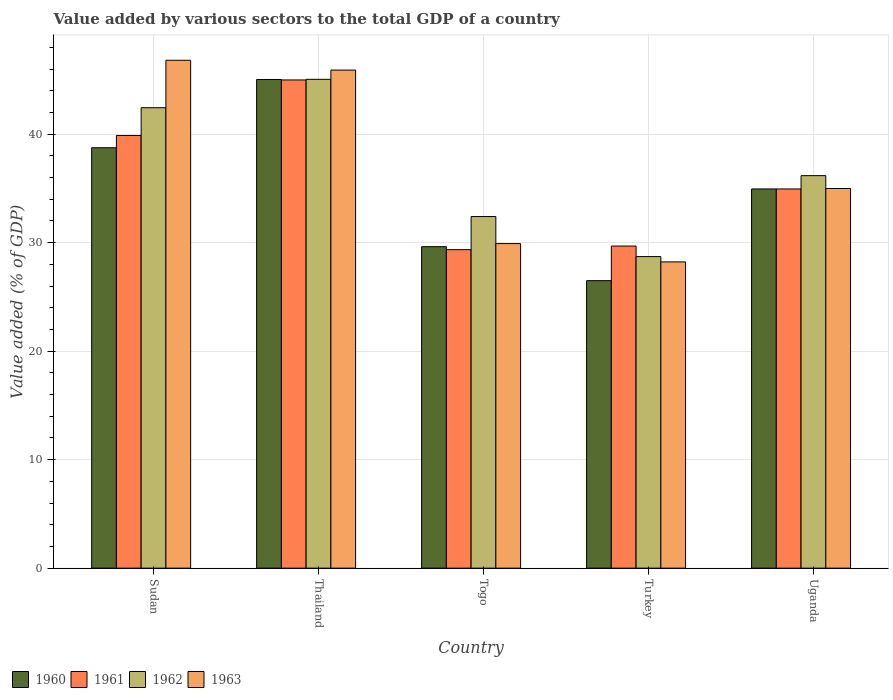Are the number of bars on each tick of the X-axis equal?
Give a very brief answer. Yes. How many bars are there on the 1st tick from the left?
Your answer should be compact. 4. What is the label of the 1st group of bars from the left?
Your answer should be very brief. Sudan. In how many cases, is the number of bars for a given country not equal to the number of legend labels?
Make the answer very short. 0. What is the value added by various sectors to the total GDP in 1962 in Turkey?
Make the answer very short. 28.72. Across all countries, what is the maximum value added by various sectors to the total GDP in 1960?
Ensure brevity in your answer.  45.04. Across all countries, what is the minimum value added by various sectors to the total GDP in 1963?
Offer a very short reply. 28.23. In which country was the value added by various sectors to the total GDP in 1963 maximum?
Offer a very short reply. Sudan. In which country was the value added by various sectors to the total GDP in 1961 minimum?
Your answer should be very brief. Togo. What is the total value added by various sectors to the total GDP in 1962 in the graph?
Offer a very short reply. 184.79. What is the difference between the value added by various sectors to the total GDP in 1960 in Sudan and that in Togo?
Ensure brevity in your answer.  9.12. What is the difference between the value added by various sectors to the total GDP in 1960 in Togo and the value added by various sectors to the total GDP in 1963 in Thailand?
Your response must be concise. -16.28. What is the average value added by various sectors to the total GDP in 1963 per country?
Your answer should be very brief. 37.17. What is the difference between the value added by various sectors to the total GDP of/in 1962 and value added by various sectors to the total GDP of/in 1960 in Turkey?
Your answer should be very brief. 2.22. What is the ratio of the value added by various sectors to the total GDP in 1963 in Thailand to that in Uganda?
Provide a succinct answer. 1.31. Is the difference between the value added by various sectors to the total GDP in 1962 in Thailand and Togo greater than the difference between the value added by various sectors to the total GDP in 1960 in Thailand and Togo?
Provide a succinct answer. No. What is the difference between the highest and the second highest value added by various sectors to the total GDP in 1961?
Offer a very short reply. -10.05. What is the difference between the highest and the lowest value added by various sectors to the total GDP in 1962?
Provide a short and direct response. 16.34. In how many countries, is the value added by various sectors to the total GDP in 1962 greater than the average value added by various sectors to the total GDP in 1962 taken over all countries?
Keep it short and to the point. 2. Is it the case that in every country, the sum of the value added by various sectors to the total GDP in 1962 and value added by various sectors to the total GDP in 1961 is greater than the sum of value added by various sectors to the total GDP in 1960 and value added by various sectors to the total GDP in 1963?
Ensure brevity in your answer.  No. What does the 3rd bar from the left in Turkey represents?
Your answer should be compact. 1962. What does the 2nd bar from the right in Thailand represents?
Your answer should be compact. 1962. Is it the case that in every country, the sum of the value added by various sectors to the total GDP in 1960 and value added by various sectors to the total GDP in 1962 is greater than the value added by various sectors to the total GDP in 1963?
Offer a very short reply. Yes. How many bars are there?
Ensure brevity in your answer.  20. Are all the bars in the graph horizontal?
Your answer should be compact. No. How many countries are there in the graph?
Keep it short and to the point. 5. What is the difference between two consecutive major ticks on the Y-axis?
Provide a short and direct response. 10. Does the graph contain grids?
Your response must be concise. Yes. Where does the legend appear in the graph?
Ensure brevity in your answer.  Bottom left. How are the legend labels stacked?
Your response must be concise. Horizontal. What is the title of the graph?
Offer a very short reply. Value added by various sectors to the total GDP of a country. What is the label or title of the X-axis?
Your answer should be compact. Country. What is the label or title of the Y-axis?
Make the answer very short. Value added (% of GDP). What is the Value added (% of GDP) in 1960 in Sudan?
Provide a short and direct response. 38.75. What is the Value added (% of GDP) in 1961 in Sudan?
Offer a terse response. 39.88. What is the Value added (% of GDP) of 1962 in Sudan?
Provide a short and direct response. 42.44. What is the Value added (% of GDP) in 1963 in Sudan?
Offer a terse response. 46.81. What is the Value added (% of GDP) of 1960 in Thailand?
Make the answer very short. 45.04. What is the Value added (% of GDP) in 1961 in Thailand?
Make the answer very short. 45. What is the Value added (% of GDP) of 1962 in Thailand?
Your response must be concise. 45.05. What is the Value added (% of GDP) of 1963 in Thailand?
Ensure brevity in your answer.  45.91. What is the Value added (% of GDP) in 1960 in Togo?
Keep it short and to the point. 29.63. What is the Value added (% of GDP) of 1961 in Togo?
Your answer should be very brief. 29.35. What is the Value added (% of GDP) in 1962 in Togo?
Your answer should be compact. 32.41. What is the Value added (% of GDP) in 1963 in Togo?
Give a very brief answer. 29.91. What is the Value added (% of GDP) of 1960 in Turkey?
Offer a very short reply. 26.5. What is the Value added (% of GDP) in 1961 in Turkey?
Your response must be concise. 29.69. What is the Value added (% of GDP) of 1962 in Turkey?
Your answer should be very brief. 28.72. What is the Value added (% of GDP) of 1963 in Turkey?
Your answer should be compact. 28.23. What is the Value added (% of GDP) in 1960 in Uganda?
Give a very brief answer. 34.95. What is the Value added (% of GDP) in 1961 in Uganda?
Keep it short and to the point. 34.95. What is the Value added (% of GDP) of 1962 in Uganda?
Make the answer very short. 36.18. What is the Value added (% of GDP) of 1963 in Uganda?
Provide a succinct answer. 34.99. Across all countries, what is the maximum Value added (% of GDP) of 1960?
Offer a very short reply. 45.04. Across all countries, what is the maximum Value added (% of GDP) of 1961?
Ensure brevity in your answer.  45. Across all countries, what is the maximum Value added (% of GDP) of 1962?
Make the answer very short. 45.05. Across all countries, what is the maximum Value added (% of GDP) in 1963?
Keep it short and to the point. 46.81. Across all countries, what is the minimum Value added (% of GDP) in 1960?
Offer a very short reply. 26.5. Across all countries, what is the minimum Value added (% of GDP) in 1961?
Offer a very short reply. 29.35. Across all countries, what is the minimum Value added (% of GDP) of 1962?
Make the answer very short. 28.72. Across all countries, what is the minimum Value added (% of GDP) in 1963?
Keep it short and to the point. 28.23. What is the total Value added (% of GDP) in 1960 in the graph?
Your answer should be very brief. 174.87. What is the total Value added (% of GDP) in 1961 in the graph?
Offer a very short reply. 178.87. What is the total Value added (% of GDP) of 1962 in the graph?
Offer a terse response. 184.79. What is the total Value added (% of GDP) in 1963 in the graph?
Make the answer very short. 185.85. What is the difference between the Value added (% of GDP) in 1960 in Sudan and that in Thailand?
Your answer should be very brief. -6.29. What is the difference between the Value added (% of GDP) of 1961 in Sudan and that in Thailand?
Keep it short and to the point. -5.12. What is the difference between the Value added (% of GDP) of 1962 in Sudan and that in Thailand?
Your response must be concise. -2.62. What is the difference between the Value added (% of GDP) in 1963 in Sudan and that in Thailand?
Ensure brevity in your answer.  0.9. What is the difference between the Value added (% of GDP) in 1960 in Sudan and that in Togo?
Keep it short and to the point. 9.12. What is the difference between the Value added (% of GDP) of 1961 in Sudan and that in Togo?
Your answer should be compact. 10.52. What is the difference between the Value added (% of GDP) in 1962 in Sudan and that in Togo?
Offer a very short reply. 10.03. What is the difference between the Value added (% of GDP) of 1963 in Sudan and that in Togo?
Ensure brevity in your answer.  16.9. What is the difference between the Value added (% of GDP) of 1960 in Sudan and that in Turkey?
Offer a terse response. 12.25. What is the difference between the Value added (% of GDP) of 1961 in Sudan and that in Turkey?
Offer a very short reply. 10.19. What is the difference between the Value added (% of GDP) in 1962 in Sudan and that in Turkey?
Make the answer very short. 13.72. What is the difference between the Value added (% of GDP) of 1963 in Sudan and that in Turkey?
Offer a very short reply. 18.58. What is the difference between the Value added (% of GDP) of 1960 in Sudan and that in Uganda?
Your response must be concise. 3.8. What is the difference between the Value added (% of GDP) of 1961 in Sudan and that in Uganda?
Give a very brief answer. 4.93. What is the difference between the Value added (% of GDP) of 1962 in Sudan and that in Uganda?
Make the answer very short. 6.26. What is the difference between the Value added (% of GDP) in 1963 in Sudan and that in Uganda?
Your answer should be very brief. 11.82. What is the difference between the Value added (% of GDP) of 1960 in Thailand and that in Togo?
Your answer should be compact. 15.41. What is the difference between the Value added (% of GDP) in 1961 in Thailand and that in Togo?
Your answer should be compact. 15.64. What is the difference between the Value added (% of GDP) of 1962 in Thailand and that in Togo?
Your answer should be compact. 12.65. What is the difference between the Value added (% of GDP) of 1963 in Thailand and that in Togo?
Your answer should be very brief. 15.99. What is the difference between the Value added (% of GDP) in 1960 in Thailand and that in Turkey?
Make the answer very short. 18.54. What is the difference between the Value added (% of GDP) in 1961 in Thailand and that in Turkey?
Provide a short and direct response. 15.31. What is the difference between the Value added (% of GDP) of 1962 in Thailand and that in Turkey?
Provide a succinct answer. 16.34. What is the difference between the Value added (% of GDP) in 1963 in Thailand and that in Turkey?
Provide a succinct answer. 17.68. What is the difference between the Value added (% of GDP) in 1960 in Thailand and that in Uganda?
Your response must be concise. 10.09. What is the difference between the Value added (% of GDP) in 1961 in Thailand and that in Uganda?
Provide a succinct answer. 10.05. What is the difference between the Value added (% of GDP) in 1962 in Thailand and that in Uganda?
Ensure brevity in your answer.  8.88. What is the difference between the Value added (% of GDP) in 1963 in Thailand and that in Uganda?
Ensure brevity in your answer.  10.92. What is the difference between the Value added (% of GDP) of 1960 in Togo and that in Turkey?
Provide a succinct answer. 3.13. What is the difference between the Value added (% of GDP) of 1961 in Togo and that in Turkey?
Give a very brief answer. -0.33. What is the difference between the Value added (% of GDP) of 1962 in Togo and that in Turkey?
Give a very brief answer. 3.69. What is the difference between the Value added (% of GDP) of 1963 in Togo and that in Turkey?
Keep it short and to the point. 1.69. What is the difference between the Value added (% of GDP) of 1960 in Togo and that in Uganda?
Ensure brevity in your answer.  -5.32. What is the difference between the Value added (% of GDP) of 1961 in Togo and that in Uganda?
Keep it short and to the point. -5.6. What is the difference between the Value added (% of GDP) of 1962 in Togo and that in Uganda?
Keep it short and to the point. -3.77. What is the difference between the Value added (% of GDP) of 1963 in Togo and that in Uganda?
Provide a succinct answer. -5.08. What is the difference between the Value added (% of GDP) in 1960 in Turkey and that in Uganda?
Your answer should be compact. -8.45. What is the difference between the Value added (% of GDP) of 1961 in Turkey and that in Uganda?
Ensure brevity in your answer.  -5.26. What is the difference between the Value added (% of GDP) of 1962 in Turkey and that in Uganda?
Give a very brief answer. -7.46. What is the difference between the Value added (% of GDP) in 1963 in Turkey and that in Uganda?
Offer a terse response. -6.76. What is the difference between the Value added (% of GDP) of 1960 in Sudan and the Value added (% of GDP) of 1961 in Thailand?
Make the answer very short. -6.25. What is the difference between the Value added (% of GDP) in 1960 in Sudan and the Value added (% of GDP) in 1962 in Thailand?
Your response must be concise. -6.31. What is the difference between the Value added (% of GDP) of 1960 in Sudan and the Value added (% of GDP) of 1963 in Thailand?
Provide a short and direct response. -7.16. What is the difference between the Value added (% of GDP) of 1961 in Sudan and the Value added (% of GDP) of 1962 in Thailand?
Offer a very short reply. -5.18. What is the difference between the Value added (% of GDP) in 1961 in Sudan and the Value added (% of GDP) in 1963 in Thailand?
Provide a succinct answer. -6.03. What is the difference between the Value added (% of GDP) in 1962 in Sudan and the Value added (% of GDP) in 1963 in Thailand?
Your response must be concise. -3.47. What is the difference between the Value added (% of GDP) of 1960 in Sudan and the Value added (% of GDP) of 1961 in Togo?
Offer a very short reply. 9.39. What is the difference between the Value added (% of GDP) of 1960 in Sudan and the Value added (% of GDP) of 1962 in Togo?
Offer a very short reply. 6.34. What is the difference between the Value added (% of GDP) in 1960 in Sudan and the Value added (% of GDP) in 1963 in Togo?
Your answer should be compact. 8.83. What is the difference between the Value added (% of GDP) of 1961 in Sudan and the Value added (% of GDP) of 1962 in Togo?
Provide a short and direct response. 7.47. What is the difference between the Value added (% of GDP) in 1961 in Sudan and the Value added (% of GDP) in 1963 in Togo?
Make the answer very short. 9.96. What is the difference between the Value added (% of GDP) of 1962 in Sudan and the Value added (% of GDP) of 1963 in Togo?
Provide a short and direct response. 12.52. What is the difference between the Value added (% of GDP) of 1960 in Sudan and the Value added (% of GDP) of 1961 in Turkey?
Give a very brief answer. 9.06. What is the difference between the Value added (% of GDP) in 1960 in Sudan and the Value added (% of GDP) in 1962 in Turkey?
Make the answer very short. 10.03. What is the difference between the Value added (% of GDP) of 1960 in Sudan and the Value added (% of GDP) of 1963 in Turkey?
Offer a very short reply. 10.52. What is the difference between the Value added (% of GDP) of 1961 in Sudan and the Value added (% of GDP) of 1962 in Turkey?
Keep it short and to the point. 11.16. What is the difference between the Value added (% of GDP) in 1961 in Sudan and the Value added (% of GDP) in 1963 in Turkey?
Offer a terse response. 11.65. What is the difference between the Value added (% of GDP) in 1962 in Sudan and the Value added (% of GDP) in 1963 in Turkey?
Provide a short and direct response. 14.21. What is the difference between the Value added (% of GDP) in 1960 in Sudan and the Value added (% of GDP) in 1961 in Uganda?
Ensure brevity in your answer.  3.8. What is the difference between the Value added (% of GDP) of 1960 in Sudan and the Value added (% of GDP) of 1962 in Uganda?
Provide a short and direct response. 2.57. What is the difference between the Value added (% of GDP) in 1960 in Sudan and the Value added (% of GDP) in 1963 in Uganda?
Provide a short and direct response. 3.76. What is the difference between the Value added (% of GDP) in 1961 in Sudan and the Value added (% of GDP) in 1962 in Uganda?
Your answer should be very brief. 3.7. What is the difference between the Value added (% of GDP) of 1961 in Sudan and the Value added (% of GDP) of 1963 in Uganda?
Ensure brevity in your answer.  4.89. What is the difference between the Value added (% of GDP) in 1962 in Sudan and the Value added (% of GDP) in 1963 in Uganda?
Give a very brief answer. 7.45. What is the difference between the Value added (% of GDP) of 1960 in Thailand and the Value added (% of GDP) of 1961 in Togo?
Give a very brief answer. 15.68. What is the difference between the Value added (% of GDP) of 1960 in Thailand and the Value added (% of GDP) of 1962 in Togo?
Give a very brief answer. 12.63. What is the difference between the Value added (% of GDP) of 1960 in Thailand and the Value added (% of GDP) of 1963 in Togo?
Your response must be concise. 15.12. What is the difference between the Value added (% of GDP) in 1961 in Thailand and the Value added (% of GDP) in 1962 in Togo?
Offer a very short reply. 12.59. What is the difference between the Value added (% of GDP) in 1961 in Thailand and the Value added (% of GDP) in 1963 in Togo?
Your answer should be very brief. 15.08. What is the difference between the Value added (% of GDP) in 1962 in Thailand and the Value added (% of GDP) in 1963 in Togo?
Your response must be concise. 15.14. What is the difference between the Value added (% of GDP) of 1960 in Thailand and the Value added (% of GDP) of 1961 in Turkey?
Give a very brief answer. 15.35. What is the difference between the Value added (% of GDP) of 1960 in Thailand and the Value added (% of GDP) of 1962 in Turkey?
Your response must be concise. 16.32. What is the difference between the Value added (% of GDP) in 1960 in Thailand and the Value added (% of GDP) in 1963 in Turkey?
Your answer should be very brief. 16.81. What is the difference between the Value added (% of GDP) of 1961 in Thailand and the Value added (% of GDP) of 1962 in Turkey?
Provide a succinct answer. 16.28. What is the difference between the Value added (% of GDP) in 1961 in Thailand and the Value added (% of GDP) in 1963 in Turkey?
Make the answer very short. 16.77. What is the difference between the Value added (% of GDP) in 1962 in Thailand and the Value added (% of GDP) in 1963 in Turkey?
Your answer should be very brief. 16.83. What is the difference between the Value added (% of GDP) of 1960 in Thailand and the Value added (% of GDP) of 1961 in Uganda?
Provide a short and direct response. 10.09. What is the difference between the Value added (% of GDP) of 1960 in Thailand and the Value added (% of GDP) of 1962 in Uganda?
Your answer should be very brief. 8.86. What is the difference between the Value added (% of GDP) in 1960 in Thailand and the Value added (% of GDP) in 1963 in Uganda?
Keep it short and to the point. 10.05. What is the difference between the Value added (% of GDP) in 1961 in Thailand and the Value added (% of GDP) in 1962 in Uganda?
Provide a short and direct response. 8.82. What is the difference between the Value added (% of GDP) in 1961 in Thailand and the Value added (% of GDP) in 1963 in Uganda?
Make the answer very short. 10.01. What is the difference between the Value added (% of GDP) of 1962 in Thailand and the Value added (% of GDP) of 1963 in Uganda?
Your response must be concise. 10.06. What is the difference between the Value added (% of GDP) in 1960 in Togo and the Value added (% of GDP) in 1961 in Turkey?
Give a very brief answer. -0.06. What is the difference between the Value added (% of GDP) of 1960 in Togo and the Value added (% of GDP) of 1962 in Turkey?
Make the answer very short. 0.91. What is the difference between the Value added (% of GDP) of 1960 in Togo and the Value added (% of GDP) of 1963 in Turkey?
Offer a very short reply. 1.4. What is the difference between the Value added (% of GDP) of 1961 in Togo and the Value added (% of GDP) of 1962 in Turkey?
Provide a succinct answer. 0.64. What is the difference between the Value added (% of GDP) in 1961 in Togo and the Value added (% of GDP) in 1963 in Turkey?
Offer a very short reply. 1.13. What is the difference between the Value added (% of GDP) of 1962 in Togo and the Value added (% of GDP) of 1963 in Turkey?
Give a very brief answer. 4.18. What is the difference between the Value added (% of GDP) in 1960 in Togo and the Value added (% of GDP) in 1961 in Uganda?
Ensure brevity in your answer.  -5.32. What is the difference between the Value added (% of GDP) in 1960 in Togo and the Value added (% of GDP) in 1962 in Uganda?
Give a very brief answer. -6.55. What is the difference between the Value added (% of GDP) of 1960 in Togo and the Value added (% of GDP) of 1963 in Uganda?
Your response must be concise. -5.36. What is the difference between the Value added (% of GDP) in 1961 in Togo and the Value added (% of GDP) in 1962 in Uganda?
Provide a short and direct response. -6.82. What is the difference between the Value added (% of GDP) in 1961 in Togo and the Value added (% of GDP) in 1963 in Uganda?
Your answer should be compact. -5.64. What is the difference between the Value added (% of GDP) of 1962 in Togo and the Value added (% of GDP) of 1963 in Uganda?
Keep it short and to the point. -2.58. What is the difference between the Value added (% of GDP) of 1960 in Turkey and the Value added (% of GDP) of 1961 in Uganda?
Your answer should be very brief. -8.45. What is the difference between the Value added (% of GDP) of 1960 in Turkey and the Value added (% of GDP) of 1962 in Uganda?
Ensure brevity in your answer.  -9.68. What is the difference between the Value added (% of GDP) of 1960 in Turkey and the Value added (% of GDP) of 1963 in Uganda?
Ensure brevity in your answer.  -8.49. What is the difference between the Value added (% of GDP) in 1961 in Turkey and the Value added (% of GDP) in 1962 in Uganda?
Provide a succinct answer. -6.49. What is the difference between the Value added (% of GDP) in 1961 in Turkey and the Value added (% of GDP) in 1963 in Uganda?
Your answer should be compact. -5.3. What is the difference between the Value added (% of GDP) of 1962 in Turkey and the Value added (% of GDP) of 1963 in Uganda?
Your response must be concise. -6.28. What is the average Value added (% of GDP) in 1960 per country?
Your response must be concise. 34.97. What is the average Value added (% of GDP) of 1961 per country?
Provide a short and direct response. 35.77. What is the average Value added (% of GDP) of 1962 per country?
Give a very brief answer. 36.96. What is the average Value added (% of GDP) in 1963 per country?
Make the answer very short. 37.17. What is the difference between the Value added (% of GDP) in 1960 and Value added (% of GDP) in 1961 in Sudan?
Your response must be concise. -1.13. What is the difference between the Value added (% of GDP) of 1960 and Value added (% of GDP) of 1962 in Sudan?
Provide a succinct answer. -3.69. What is the difference between the Value added (% of GDP) in 1960 and Value added (% of GDP) in 1963 in Sudan?
Make the answer very short. -8.06. What is the difference between the Value added (% of GDP) of 1961 and Value added (% of GDP) of 1962 in Sudan?
Provide a short and direct response. -2.56. What is the difference between the Value added (% of GDP) in 1961 and Value added (% of GDP) in 1963 in Sudan?
Your answer should be very brief. -6.93. What is the difference between the Value added (% of GDP) in 1962 and Value added (% of GDP) in 1963 in Sudan?
Your answer should be compact. -4.37. What is the difference between the Value added (% of GDP) of 1960 and Value added (% of GDP) of 1961 in Thailand?
Your answer should be compact. 0.04. What is the difference between the Value added (% of GDP) of 1960 and Value added (% of GDP) of 1962 in Thailand?
Give a very brief answer. -0.02. What is the difference between the Value added (% of GDP) of 1960 and Value added (% of GDP) of 1963 in Thailand?
Give a very brief answer. -0.87. What is the difference between the Value added (% of GDP) of 1961 and Value added (% of GDP) of 1962 in Thailand?
Offer a very short reply. -0.06. What is the difference between the Value added (% of GDP) in 1961 and Value added (% of GDP) in 1963 in Thailand?
Provide a succinct answer. -0.91. What is the difference between the Value added (% of GDP) in 1962 and Value added (% of GDP) in 1963 in Thailand?
Your answer should be very brief. -0.85. What is the difference between the Value added (% of GDP) of 1960 and Value added (% of GDP) of 1961 in Togo?
Your response must be concise. 0.27. What is the difference between the Value added (% of GDP) in 1960 and Value added (% of GDP) in 1962 in Togo?
Offer a very short reply. -2.78. What is the difference between the Value added (% of GDP) in 1960 and Value added (% of GDP) in 1963 in Togo?
Your answer should be very brief. -0.28. What is the difference between the Value added (% of GDP) in 1961 and Value added (% of GDP) in 1962 in Togo?
Your answer should be very brief. -3.05. What is the difference between the Value added (% of GDP) of 1961 and Value added (% of GDP) of 1963 in Togo?
Your answer should be compact. -0.56. What is the difference between the Value added (% of GDP) of 1962 and Value added (% of GDP) of 1963 in Togo?
Provide a short and direct response. 2.49. What is the difference between the Value added (% of GDP) in 1960 and Value added (% of GDP) in 1961 in Turkey?
Give a very brief answer. -3.19. What is the difference between the Value added (% of GDP) in 1960 and Value added (% of GDP) in 1962 in Turkey?
Keep it short and to the point. -2.22. What is the difference between the Value added (% of GDP) in 1960 and Value added (% of GDP) in 1963 in Turkey?
Your answer should be very brief. -1.73. What is the difference between the Value added (% of GDP) of 1961 and Value added (% of GDP) of 1962 in Turkey?
Provide a succinct answer. 0.97. What is the difference between the Value added (% of GDP) of 1961 and Value added (% of GDP) of 1963 in Turkey?
Give a very brief answer. 1.46. What is the difference between the Value added (% of GDP) in 1962 and Value added (% of GDP) in 1963 in Turkey?
Provide a short and direct response. 0.49. What is the difference between the Value added (% of GDP) of 1960 and Value added (% of GDP) of 1961 in Uganda?
Your answer should be compact. -0. What is the difference between the Value added (% of GDP) in 1960 and Value added (% of GDP) in 1962 in Uganda?
Keep it short and to the point. -1.23. What is the difference between the Value added (% of GDP) of 1960 and Value added (% of GDP) of 1963 in Uganda?
Offer a very short reply. -0.04. What is the difference between the Value added (% of GDP) of 1961 and Value added (% of GDP) of 1962 in Uganda?
Your answer should be very brief. -1.23. What is the difference between the Value added (% of GDP) of 1961 and Value added (% of GDP) of 1963 in Uganda?
Make the answer very short. -0.04. What is the difference between the Value added (% of GDP) in 1962 and Value added (% of GDP) in 1963 in Uganda?
Offer a terse response. 1.18. What is the ratio of the Value added (% of GDP) in 1960 in Sudan to that in Thailand?
Your response must be concise. 0.86. What is the ratio of the Value added (% of GDP) of 1961 in Sudan to that in Thailand?
Your answer should be very brief. 0.89. What is the ratio of the Value added (% of GDP) of 1962 in Sudan to that in Thailand?
Make the answer very short. 0.94. What is the ratio of the Value added (% of GDP) in 1963 in Sudan to that in Thailand?
Provide a succinct answer. 1.02. What is the ratio of the Value added (% of GDP) in 1960 in Sudan to that in Togo?
Offer a very short reply. 1.31. What is the ratio of the Value added (% of GDP) in 1961 in Sudan to that in Togo?
Give a very brief answer. 1.36. What is the ratio of the Value added (% of GDP) in 1962 in Sudan to that in Togo?
Ensure brevity in your answer.  1.31. What is the ratio of the Value added (% of GDP) of 1963 in Sudan to that in Togo?
Ensure brevity in your answer.  1.56. What is the ratio of the Value added (% of GDP) of 1960 in Sudan to that in Turkey?
Make the answer very short. 1.46. What is the ratio of the Value added (% of GDP) in 1961 in Sudan to that in Turkey?
Give a very brief answer. 1.34. What is the ratio of the Value added (% of GDP) of 1962 in Sudan to that in Turkey?
Make the answer very short. 1.48. What is the ratio of the Value added (% of GDP) in 1963 in Sudan to that in Turkey?
Give a very brief answer. 1.66. What is the ratio of the Value added (% of GDP) in 1960 in Sudan to that in Uganda?
Your response must be concise. 1.11. What is the ratio of the Value added (% of GDP) in 1961 in Sudan to that in Uganda?
Your answer should be compact. 1.14. What is the ratio of the Value added (% of GDP) in 1962 in Sudan to that in Uganda?
Provide a short and direct response. 1.17. What is the ratio of the Value added (% of GDP) in 1963 in Sudan to that in Uganda?
Provide a short and direct response. 1.34. What is the ratio of the Value added (% of GDP) in 1960 in Thailand to that in Togo?
Your answer should be very brief. 1.52. What is the ratio of the Value added (% of GDP) in 1961 in Thailand to that in Togo?
Your response must be concise. 1.53. What is the ratio of the Value added (% of GDP) of 1962 in Thailand to that in Togo?
Offer a terse response. 1.39. What is the ratio of the Value added (% of GDP) of 1963 in Thailand to that in Togo?
Provide a succinct answer. 1.53. What is the ratio of the Value added (% of GDP) of 1960 in Thailand to that in Turkey?
Provide a succinct answer. 1.7. What is the ratio of the Value added (% of GDP) in 1961 in Thailand to that in Turkey?
Make the answer very short. 1.52. What is the ratio of the Value added (% of GDP) in 1962 in Thailand to that in Turkey?
Keep it short and to the point. 1.57. What is the ratio of the Value added (% of GDP) of 1963 in Thailand to that in Turkey?
Provide a short and direct response. 1.63. What is the ratio of the Value added (% of GDP) of 1960 in Thailand to that in Uganda?
Your response must be concise. 1.29. What is the ratio of the Value added (% of GDP) in 1961 in Thailand to that in Uganda?
Offer a very short reply. 1.29. What is the ratio of the Value added (% of GDP) of 1962 in Thailand to that in Uganda?
Provide a succinct answer. 1.25. What is the ratio of the Value added (% of GDP) in 1963 in Thailand to that in Uganda?
Keep it short and to the point. 1.31. What is the ratio of the Value added (% of GDP) of 1960 in Togo to that in Turkey?
Offer a very short reply. 1.12. What is the ratio of the Value added (% of GDP) in 1961 in Togo to that in Turkey?
Offer a very short reply. 0.99. What is the ratio of the Value added (% of GDP) of 1962 in Togo to that in Turkey?
Give a very brief answer. 1.13. What is the ratio of the Value added (% of GDP) of 1963 in Togo to that in Turkey?
Your answer should be very brief. 1.06. What is the ratio of the Value added (% of GDP) in 1960 in Togo to that in Uganda?
Your answer should be compact. 0.85. What is the ratio of the Value added (% of GDP) in 1961 in Togo to that in Uganda?
Provide a short and direct response. 0.84. What is the ratio of the Value added (% of GDP) in 1962 in Togo to that in Uganda?
Your answer should be compact. 0.9. What is the ratio of the Value added (% of GDP) of 1963 in Togo to that in Uganda?
Keep it short and to the point. 0.85. What is the ratio of the Value added (% of GDP) in 1960 in Turkey to that in Uganda?
Your answer should be compact. 0.76. What is the ratio of the Value added (% of GDP) in 1961 in Turkey to that in Uganda?
Your answer should be very brief. 0.85. What is the ratio of the Value added (% of GDP) in 1962 in Turkey to that in Uganda?
Offer a very short reply. 0.79. What is the ratio of the Value added (% of GDP) of 1963 in Turkey to that in Uganda?
Keep it short and to the point. 0.81. What is the difference between the highest and the second highest Value added (% of GDP) in 1960?
Your response must be concise. 6.29. What is the difference between the highest and the second highest Value added (% of GDP) of 1961?
Keep it short and to the point. 5.12. What is the difference between the highest and the second highest Value added (% of GDP) in 1962?
Keep it short and to the point. 2.62. What is the difference between the highest and the second highest Value added (% of GDP) of 1963?
Your answer should be very brief. 0.9. What is the difference between the highest and the lowest Value added (% of GDP) of 1960?
Offer a very short reply. 18.54. What is the difference between the highest and the lowest Value added (% of GDP) of 1961?
Provide a short and direct response. 15.64. What is the difference between the highest and the lowest Value added (% of GDP) in 1962?
Give a very brief answer. 16.34. What is the difference between the highest and the lowest Value added (% of GDP) in 1963?
Provide a short and direct response. 18.58. 